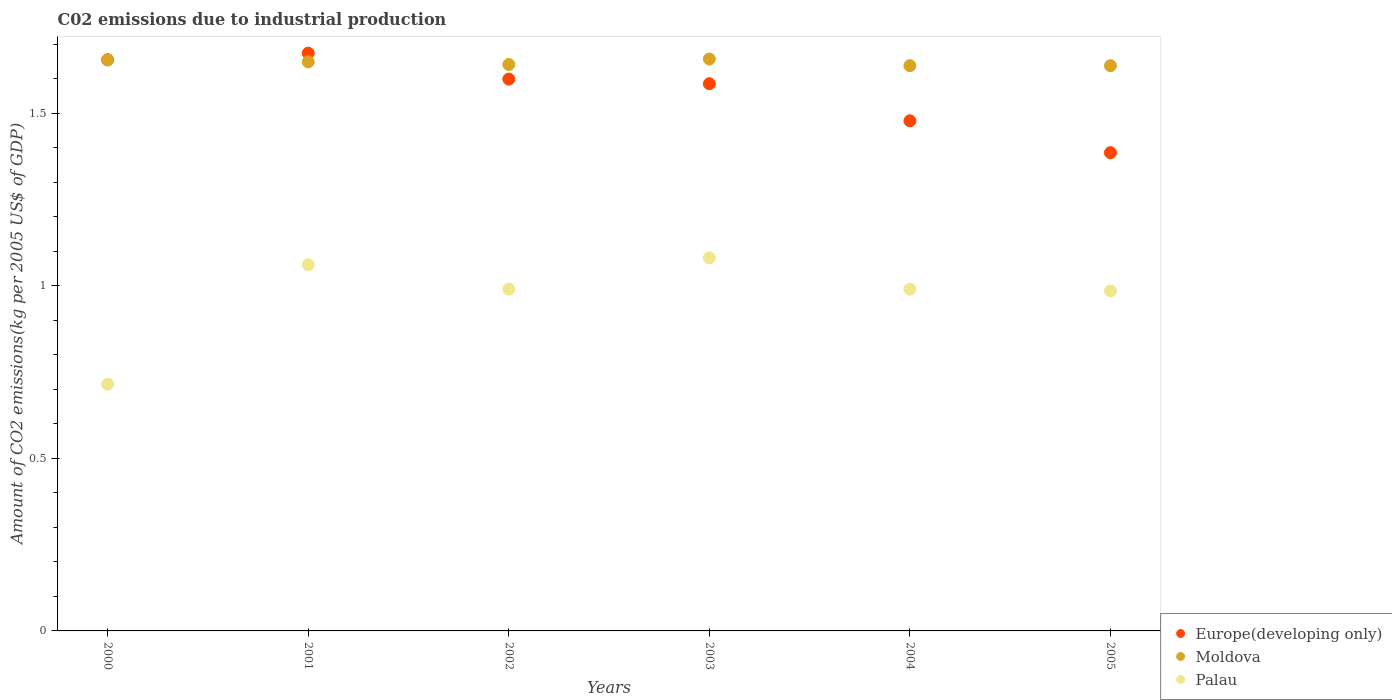What is the amount of CO2 emitted due to industrial production in Palau in 2005?
Keep it short and to the point. 0.99. Across all years, what is the maximum amount of CO2 emitted due to industrial production in Moldova?
Offer a terse response. 1.66. Across all years, what is the minimum amount of CO2 emitted due to industrial production in Europe(developing only)?
Your response must be concise. 1.39. What is the total amount of CO2 emitted due to industrial production in Palau in the graph?
Keep it short and to the point. 5.82. What is the difference between the amount of CO2 emitted due to industrial production in Moldova in 2003 and that in 2005?
Offer a terse response. 0.02. What is the difference between the amount of CO2 emitted due to industrial production in Europe(developing only) in 2002 and the amount of CO2 emitted due to industrial production in Moldova in 2003?
Offer a very short reply. -0.06. What is the average amount of CO2 emitted due to industrial production in Palau per year?
Your answer should be compact. 0.97. In the year 2002, what is the difference between the amount of CO2 emitted due to industrial production in Europe(developing only) and amount of CO2 emitted due to industrial production in Moldova?
Make the answer very short. -0.04. In how many years, is the amount of CO2 emitted due to industrial production in Europe(developing only) greater than 1.4 kg?
Provide a short and direct response. 5. What is the ratio of the amount of CO2 emitted due to industrial production in Europe(developing only) in 2003 to that in 2004?
Keep it short and to the point. 1.07. Is the difference between the amount of CO2 emitted due to industrial production in Europe(developing only) in 2001 and 2004 greater than the difference between the amount of CO2 emitted due to industrial production in Moldova in 2001 and 2004?
Your answer should be compact. Yes. What is the difference between the highest and the second highest amount of CO2 emitted due to industrial production in Moldova?
Offer a very short reply. 0. What is the difference between the highest and the lowest amount of CO2 emitted due to industrial production in Moldova?
Provide a short and direct response. 0.02. In how many years, is the amount of CO2 emitted due to industrial production in Palau greater than the average amount of CO2 emitted due to industrial production in Palau taken over all years?
Keep it short and to the point. 5. How many years are there in the graph?
Your answer should be very brief. 6. Are the values on the major ticks of Y-axis written in scientific E-notation?
Ensure brevity in your answer.  No. Where does the legend appear in the graph?
Ensure brevity in your answer.  Bottom right. What is the title of the graph?
Give a very brief answer. C02 emissions due to industrial production. What is the label or title of the X-axis?
Keep it short and to the point. Years. What is the label or title of the Y-axis?
Make the answer very short. Amount of CO2 emissions(kg per 2005 US$ of GDP). What is the Amount of CO2 emissions(kg per 2005 US$ of GDP) in Europe(developing only) in 2000?
Make the answer very short. 1.66. What is the Amount of CO2 emissions(kg per 2005 US$ of GDP) in Moldova in 2000?
Ensure brevity in your answer.  1.65. What is the Amount of CO2 emissions(kg per 2005 US$ of GDP) of Palau in 2000?
Offer a terse response. 0.71. What is the Amount of CO2 emissions(kg per 2005 US$ of GDP) in Europe(developing only) in 2001?
Give a very brief answer. 1.67. What is the Amount of CO2 emissions(kg per 2005 US$ of GDP) in Moldova in 2001?
Your answer should be very brief. 1.65. What is the Amount of CO2 emissions(kg per 2005 US$ of GDP) of Palau in 2001?
Your response must be concise. 1.06. What is the Amount of CO2 emissions(kg per 2005 US$ of GDP) in Europe(developing only) in 2002?
Make the answer very short. 1.6. What is the Amount of CO2 emissions(kg per 2005 US$ of GDP) in Moldova in 2002?
Keep it short and to the point. 1.64. What is the Amount of CO2 emissions(kg per 2005 US$ of GDP) of Palau in 2002?
Provide a short and direct response. 0.99. What is the Amount of CO2 emissions(kg per 2005 US$ of GDP) of Europe(developing only) in 2003?
Your response must be concise. 1.59. What is the Amount of CO2 emissions(kg per 2005 US$ of GDP) in Moldova in 2003?
Make the answer very short. 1.66. What is the Amount of CO2 emissions(kg per 2005 US$ of GDP) of Palau in 2003?
Offer a terse response. 1.08. What is the Amount of CO2 emissions(kg per 2005 US$ of GDP) of Europe(developing only) in 2004?
Your response must be concise. 1.48. What is the Amount of CO2 emissions(kg per 2005 US$ of GDP) of Moldova in 2004?
Offer a very short reply. 1.64. What is the Amount of CO2 emissions(kg per 2005 US$ of GDP) in Palau in 2004?
Offer a very short reply. 0.99. What is the Amount of CO2 emissions(kg per 2005 US$ of GDP) in Europe(developing only) in 2005?
Provide a succinct answer. 1.39. What is the Amount of CO2 emissions(kg per 2005 US$ of GDP) of Moldova in 2005?
Make the answer very short. 1.64. What is the Amount of CO2 emissions(kg per 2005 US$ of GDP) in Palau in 2005?
Offer a terse response. 0.99. Across all years, what is the maximum Amount of CO2 emissions(kg per 2005 US$ of GDP) in Europe(developing only)?
Keep it short and to the point. 1.67. Across all years, what is the maximum Amount of CO2 emissions(kg per 2005 US$ of GDP) in Moldova?
Ensure brevity in your answer.  1.66. Across all years, what is the maximum Amount of CO2 emissions(kg per 2005 US$ of GDP) in Palau?
Offer a very short reply. 1.08. Across all years, what is the minimum Amount of CO2 emissions(kg per 2005 US$ of GDP) in Europe(developing only)?
Your answer should be very brief. 1.39. Across all years, what is the minimum Amount of CO2 emissions(kg per 2005 US$ of GDP) of Moldova?
Your answer should be compact. 1.64. Across all years, what is the minimum Amount of CO2 emissions(kg per 2005 US$ of GDP) of Palau?
Your answer should be compact. 0.71. What is the total Amount of CO2 emissions(kg per 2005 US$ of GDP) of Europe(developing only) in the graph?
Your response must be concise. 9.38. What is the total Amount of CO2 emissions(kg per 2005 US$ of GDP) of Moldova in the graph?
Offer a terse response. 9.88. What is the total Amount of CO2 emissions(kg per 2005 US$ of GDP) in Palau in the graph?
Keep it short and to the point. 5.82. What is the difference between the Amount of CO2 emissions(kg per 2005 US$ of GDP) in Europe(developing only) in 2000 and that in 2001?
Give a very brief answer. -0.02. What is the difference between the Amount of CO2 emissions(kg per 2005 US$ of GDP) in Moldova in 2000 and that in 2001?
Ensure brevity in your answer.  0.01. What is the difference between the Amount of CO2 emissions(kg per 2005 US$ of GDP) in Palau in 2000 and that in 2001?
Make the answer very short. -0.35. What is the difference between the Amount of CO2 emissions(kg per 2005 US$ of GDP) of Europe(developing only) in 2000 and that in 2002?
Keep it short and to the point. 0.06. What is the difference between the Amount of CO2 emissions(kg per 2005 US$ of GDP) in Moldova in 2000 and that in 2002?
Ensure brevity in your answer.  0.01. What is the difference between the Amount of CO2 emissions(kg per 2005 US$ of GDP) of Palau in 2000 and that in 2002?
Your response must be concise. -0.28. What is the difference between the Amount of CO2 emissions(kg per 2005 US$ of GDP) in Europe(developing only) in 2000 and that in 2003?
Offer a terse response. 0.07. What is the difference between the Amount of CO2 emissions(kg per 2005 US$ of GDP) of Moldova in 2000 and that in 2003?
Make the answer very short. -0. What is the difference between the Amount of CO2 emissions(kg per 2005 US$ of GDP) in Palau in 2000 and that in 2003?
Keep it short and to the point. -0.37. What is the difference between the Amount of CO2 emissions(kg per 2005 US$ of GDP) in Europe(developing only) in 2000 and that in 2004?
Ensure brevity in your answer.  0.18. What is the difference between the Amount of CO2 emissions(kg per 2005 US$ of GDP) in Moldova in 2000 and that in 2004?
Offer a very short reply. 0.02. What is the difference between the Amount of CO2 emissions(kg per 2005 US$ of GDP) in Palau in 2000 and that in 2004?
Give a very brief answer. -0.28. What is the difference between the Amount of CO2 emissions(kg per 2005 US$ of GDP) of Europe(developing only) in 2000 and that in 2005?
Make the answer very short. 0.27. What is the difference between the Amount of CO2 emissions(kg per 2005 US$ of GDP) in Moldova in 2000 and that in 2005?
Give a very brief answer. 0.02. What is the difference between the Amount of CO2 emissions(kg per 2005 US$ of GDP) of Palau in 2000 and that in 2005?
Offer a very short reply. -0.27. What is the difference between the Amount of CO2 emissions(kg per 2005 US$ of GDP) of Europe(developing only) in 2001 and that in 2002?
Your answer should be very brief. 0.08. What is the difference between the Amount of CO2 emissions(kg per 2005 US$ of GDP) of Moldova in 2001 and that in 2002?
Keep it short and to the point. 0.01. What is the difference between the Amount of CO2 emissions(kg per 2005 US$ of GDP) of Palau in 2001 and that in 2002?
Your response must be concise. 0.07. What is the difference between the Amount of CO2 emissions(kg per 2005 US$ of GDP) in Europe(developing only) in 2001 and that in 2003?
Give a very brief answer. 0.09. What is the difference between the Amount of CO2 emissions(kg per 2005 US$ of GDP) in Moldova in 2001 and that in 2003?
Provide a succinct answer. -0.01. What is the difference between the Amount of CO2 emissions(kg per 2005 US$ of GDP) of Palau in 2001 and that in 2003?
Make the answer very short. -0.02. What is the difference between the Amount of CO2 emissions(kg per 2005 US$ of GDP) of Europe(developing only) in 2001 and that in 2004?
Make the answer very short. 0.2. What is the difference between the Amount of CO2 emissions(kg per 2005 US$ of GDP) in Moldova in 2001 and that in 2004?
Your response must be concise. 0.01. What is the difference between the Amount of CO2 emissions(kg per 2005 US$ of GDP) in Palau in 2001 and that in 2004?
Your response must be concise. 0.07. What is the difference between the Amount of CO2 emissions(kg per 2005 US$ of GDP) of Europe(developing only) in 2001 and that in 2005?
Provide a succinct answer. 0.29. What is the difference between the Amount of CO2 emissions(kg per 2005 US$ of GDP) of Moldova in 2001 and that in 2005?
Your response must be concise. 0.01. What is the difference between the Amount of CO2 emissions(kg per 2005 US$ of GDP) in Palau in 2001 and that in 2005?
Keep it short and to the point. 0.08. What is the difference between the Amount of CO2 emissions(kg per 2005 US$ of GDP) in Europe(developing only) in 2002 and that in 2003?
Ensure brevity in your answer.  0.01. What is the difference between the Amount of CO2 emissions(kg per 2005 US$ of GDP) in Moldova in 2002 and that in 2003?
Give a very brief answer. -0.02. What is the difference between the Amount of CO2 emissions(kg per 2005 US$ of GDP) in Palau in 2002 and that in 2003?
Ensure brevity in your answer.  -0.09. What is the difference between the Amount of CO2 emissions(kg per 2005 US$ of GDP) in Europe(developing only) in 2002 and that in 2004?
Provide a succinct answer. 0.12. What is the difference between the Amount of CO2 emissions(kg per 2005 US$ of GDP) of Moldova in 2002 and that in 2004?
Ensure brevity in your answer.  0. What is the difference between the Amount of CO2 emissions(kg per 2005 US$ of GDP) in Europe(developing only) in 2002 and that in 2005?
Offer a terse response. 0.21. What is the difference between the Amount of CO2 emissions(kg per 2005 US$ of GDP) of Moldova in 2002 and that in 2005?
Provide a succinct answer. 0. What is the difference between the Amount of CO2 emissions(kg per 2005 US$ of GDP) of Palau in 2002 and that in 2005?
Your answer should be compact. 0.01. What is the difference between the Amount of CO2 emissions(kg per 2005 US$ of GDP) in Europe(developing only) in 2003 and that in 2004?
Offer a very short reply. 0.11. What is the difference between the Amount of CO2 emissions(kg per 2005 US$ of GDP) in Moldova in 2003 and that in 2004?
Offer a very short reply. 0.02. What is the difference between the Amount of CO2 emissions(kg per 2005 US$ of GDP) in Palau in 2003 and that in 2004?
Ensure brevity in your answer.  0.09. What is the difference between the Amount of CO2 emissions(kg per 2005 US$ of GDP) in Europe(developing only) in 2003 and that in 2005?
Ensure brevity in your answer.  0.2. What is the difference between the Amount of CO2 emissions(kg per 2005 US$ of GDP) in Moldova in 2003 and that in 2005?
Your response must be concise. 0.02. What is the difference between the Amount of CO2 emissions(kg per 2005 US$ of GDP) in Palau in 2003 and that in 2005?
Provide a short and direct response. 0.1. What is the difference between the Amount of CO2 emissions(kg per 2005 US$ of GDP) of Europe(developing only) in 2004 and that in 2005?
Offer a very short reply. 0.09. What is the difference between the Amount of CO2 emissions(kg per 2005 US$ of GDP) in Moldova in 2004 and that in 2005?
Your answer should be very brief. -0. What is the difference between the Amount of CO2 emissions(kg per 2005 US$ of GDP) of Palau in 2004 and that in 2005?
Offer a very short reply. 0.01. What is the difference between the Amount of CO2 emissions(kg per 2005 US$ of GDP) of Europe(developing only) in 2000 and the Amount of CO2 emissions(kg per 2005 US$ of GDP) of Moldova in 2001?
Keep it short and to the point. 0.01. What is the difference between the Amount of CO2 emissions(kg per 2005 US$ of GDP) of Europe(developing only) in 2000 and the Amount of CO2 emissions(kg per 2005 US$ of GDP) of Palau in 2001?
Make the answer very short. 0.59. What is the difference between the Amount of CO2 emissions(kg per 2005 US$ of GDP) of Moldova in 2000 and the Amount of CO2 emissions(kg per 2005 US$ of GDP) of Palau in 2001?
Provide a succinct answer. 0.59. What is the difference between the Amount of CO2 emissions(kg per 2005 US$ of GDP) of Europe(developing only) in 2000 and the Amount of CO2 emissions(kg per 2005 US$ of GDP) of Moldova in 2002?
Make the answer very short. 0.01. What is the difference between the Amount of CO2 emissions(kg per 2005 US$ of GDP) in Europe(developing only) in 2000 and the Amount of CO2 emissions(kg per 2005 US$ of GDP) in Palau in 2002?
Give a very brief answer. 0.66. What is the difference between the Amount of CO2 emissions(kg per 2005 US$ of GDP) in Moldova in 2000 and the Amount of CO2 emissions(kg per 2005 US$ of GDP) in Palau in 2002?
Give a very brief answer. 0.66. What is the difference between the Amount of CO2 emissions(kg per 2005 US$ of GDP) in Europe(developing only) in 2000 and the Amount of CO2 emissions(kg per 2005 US$ of GDP) in Moldova in 2003?
Ensure brevity in your answer.  -0. What is the difference between the Amount of CO2 emissions(kg per 2005 US$ of GDP) in Europe(developing only) in 2000 and the Amount of CO2 emissions(kg per 2005 US$ of GDP) in Palau in 2003?
Your answer should be compact. 0.57. What is the difference between the Amount of CO2 emissions(kg per 2005 US$ of GDP) of Moldova in 2000 and the Amount of CO2 emissions(kg per 2005 US$ of GDP) of Palau in 2003?
Your answer should be compact. 0.57. What is the difference between the Amount of CO2 emissions(kg per 2005 US$ of GDP) of Europe(developing only) in 2000 and the Amount of CO2 emissions(kg per 2005 US$ of GDP) of Moldova in 2004?
Ensure brevity in your answer.  0.02. What is the difference between the Amount of CO2 emissions(kg per 2005 US$ of GDP) of Europe(developing only) in 2000 and the Amount of CO2 emissions(kg per 2005 US$ of GDP) of Palau in 2004?
Give a very brief answer. 0.67. What is the difference between the Amount of CO2 emissions(kg per 2005 US$ of GDP) of Moldova in 2000 and the Amount of CO2 emissions(kg per 2005 US$ of GDP) of Palau in 2004?
Your response must be concise. 0.66. What is the difference between the Amount of CO2 emissions(kg per 2005 US$ of GDP) in Europe(developing only) in 2000 and the Amount of CO2 emissions(kg per 2005 US$ of GDP) in Moldova in 2005?
Offer a very short reply. 0.02. What is the difference between the Amount of CO2 emissions(kg per 2005 US$ of GDP) of Europe(developing only) in 2000 and the Amount of CO2 emissions(kg per 2005 US$ of GDP) of Palau in 2005?
Offer a terse response. 0.67. What is the difference between the Amount of CO2 emissions(kg per 2005 US$ of GDP) of Moldova in 2000 and the Amount of CO2 emissions(kg per 2005 US$ of GDP) of Palau in 2005?
Ensure brevity in your answer.  0.67. What is the difference between the Amount of CO2 emissions(kg per 2005 US$ of GDP) in Europe(developing only) in 2001 and the Amount of CO2 emissions(kg per 2005 US$ of GDP) in Moldova in 2002?
Your answer should be very brief. 0.03. What is the difference between the Amount of CO2 emissions(kg per 2005 US$ of GDP) in Europe(developing only) in 2001 and the Amount of CO2 emissions(kg per 2005 US$ of GDP) in Palau in 2002?
Provide a succinct answer. 0.68. What is the difference between the Amount of CO2 emissions(kg per 2005 US$ of GDP) of Moldova in 2001 and the Amount of CO2 emissions(kg per 2005 US$ of GDP) of Palau in 2002?
Your response must be concise. 0.66. What is the difference between the Amount of CO2 emissions(kg per 2005 US$ of GDP) in Europe(developing only) in 2001 and the Amount of CO2 emissions(kg per 2005 US$ of GDP) in Moldova in 2003?
Offer a terse response. 0.02. What is the difference between the Amount of CO2 emissions(kg per 2005 US$ of GDP) in Europe(developing only) in 2001 and the Amount of CO2 emissions(kg per 2005 US$ of GDP) in Palau in 2003?
Provide a short and direct response. 0.59. What is the difference between the Amount of CO2 emissions(kg per 2005 US$ of GDP) in Moldova in 2001 and the Amount of CO2 emissions(kg per 2005 US$ of GDP) in Palau in 2003?
Keep it short and to the point. 0.57. What is the difference between the Amount of CO2 emissions(kg per 2005 US$ of GDP) of Europe(developing only) in 2001 and the Amount of CO2 emissions(kg per 2005 US$ of GDP) of Moldova in 2004?
Your response must be concise. 0.04. What is the difference between the Amount of CO2 emissions(kg per 2005 US$ of GDP) in Europe(developing only) in 2001 and the Amount of CO2 emissions(kg per 2005 US$ of GDP) in Palau in 2004?
Offer a terse response. 0.68. What is the difference between the Amount of CO2 emissions(kg per 2005 US$ of GDP) of Moldova in 2001 and the Amount of CO2 emissions(kg per 2005 US$ of GDP) of Palau in 2004?
Offer a terse response. 0.66. What is the difference between the Amount of CO2 emissions(kg per 2005 US$ of GDP) in Europe(developing only) in 2001 and the Amount of CO2 emissions(kg per 2005 US$ of GDP) in Moldova in 2005?
Offer a terse response. 0.04. What is the difference between the Amount of CO2 emissions(kg per 2005 US$ of GDP) in Europe(developing only) in 2001 and the Amount of CO2 emissions(kg per 2005 US$ of GDP) in Palau in 2005?
Your response must be concise. 0.69. What is the difference between the Amount of CO2 emissions(kg per 2005 US$ of GDP) in Moldova in 2001 and the Amount of CO2 emissions(kg per 2005 US$ of GDP) in Palau in 2005?
Your answer should be very brief. 0.66. What is the difference between the Amount of CO2 emissions(kg per 2005 US$ of GDP) in Europe(developing only) in 2002 and the Amount of CO2 emissions(kg per 2005 US$ of GDP) in Moldova in 2003?
Keep it short and to the point. -0.06. What is the difference between the Amount of CO2 emissions(kg per 2005 US$ of GDP) in Europe(developing only) in 2002 and the Amount of CO2 emissions(kg per 2005 US$ of GDP) in Palau in 2003?
Your response must be concise. 0.52. What is the difference between the Amount of CO2 emissions(kg per 2005 US$ of GDP) in Moldova in 2002 and the Amount of CO2 emissions(kg per 2005 US$ of GDP) in Palau in 2003?
Make the answer very short. 0.56. What is the difference between the Amount of CO2 emissions(kg per 2005 US$ of GDP) in Europe(developing only) in 2002 and the Amount of CO2 emissions(kg per 2005 US$ of GDP) in Moldova in 2004?
Your response must be concise. -0.04. What is the difference between the Amount of CO2 emissions(kg per 2005 US$ of GDP) of Europe(developing only) in 2002 and the Amount of CO2 emissions(kg per 2005 US$ of GDP) of Palau in 2004?
Your response must be concise. 0.61. What is the difference between the Amount of CO2 emissions(kg per 2005 US$ of GDP) of Moldova in 2002 and the Amount of CO2 emissions(kg per 2005 US$ of GDP) of Palau in 2004?
Your answer should be very brief. 0.65. What is the difference between the Amount of CO2 emissions(kg per 2005 US$ of GDP) in Europe(developing only) in 2002 and the Amount of CO2 emissions(kg per 2005 US$ of GDP) in Moldova in 2005?
Make the answer very short. -0.04. What is the difference between the Amount of CO2 emissions(kg per 2005 US$ of GDP) in Europe(developing only) in 2002 and the Amount of CO2 emissions(kg per 2005 US$ of GDP) in Palau in 2005?
Keep it short and to the point. 0.61. What is the difference between the Amount of CO2 emissions(kg per 2005 US$ of GDP) of Moldova in 2002 and the Amount of CO2 emissions(kg per 2005 US$ of GDP) of Palau in 2005?
Offer a very short reply. 0.66. What is the difference between the Amount of CO2 emissions(kg per 2005 US$ of GDP) of Europe(developing only) in 2003 and the Amount of CO2 emissions(kg per 2005 US$ of GDP) of Moldova in 2004?
Ensure brevity in your answer.  -0.05. What is the difference between the Amount of CO2 emissions(kg per 2005 US$ of GDP) in Europe(developing only) in 2003 and the Amount of CO2 emissions(kg per 2005 US$ of GDP) in Palau in 2004?
Your answer should be very brief. 0.6. What is the difference between the Amount of CO2 emissions(kg per 2005 US$ of GDP) in Moldova in 2003 and the Amount of CO2 emissions(kg per 2005 US$ of GDP) in Palau in 2004?
Offer a terse response. 0.67. What is the difference between the Amount of CO2 emissions(kg per 2005 US$ of GDP) of Europe(developing only) in 2003 and the Amount of CO2 emissions(kg per 2005 US$ of GDP) of Moldova in 2005?
Make the answer very short. -0.05. What is the difference between the Amount of CO2 emissions(kg per 2005 US$ of GDP) of Europe(developing only) in 2003 and the Amount of CO2 emissions(kg per 2005 US$ of GDP) of Palau in 2005?
Provide a short and direct response. 0.6. What is the difference between the Amount of CO2 emissions(kg per 2005 US$ of GDP) of Moldova in 2003 and the Amount of CO2 emissions(kg per 2005 US$ of GDP) of Palau in 2005?
Provide a succinct answer. 0.67. What is the difference between the Amount of CO2 emissions(kg per 2005 US$ of GDP) of Europe(developing only) in 2004 and the Amount of CO2 emissions(kg per 2005 US$ of GDP) of Moldova in 2005?
Your response must be concise. -0.16. What is the difference between the Amount of CO2 emissions(kg per 2005 US$ of GDP) in Europe(developing only) in 2004 and the Amount of CO2 emissions(kg per 2005 US$ of GDP) in Palau in 2005?
Give a very brief answer. 0.49. What is the difference between the Amount of CO2 emissions(kg per 2005 US$ of GDP) of Moldova in 2004 and the Amount of CO2 emissions(kg per 2005 US$ of GDP) of Palau in 2005?
Offer a terse response. 0.65. What is the average Amount of CO2 emissions(kg per 2005 US$ of GDP) in Europe(developing only) per year?
Your answer should be very brief. 1.56. What is the average Amount of CO2 emissions(kg per 2005 US$ of GDP) of Moldova per year?
Offer a terse response. 1.65. What is the average Amount of CO2 emissions(kg per 2005 US$ of GDP) of Palau per year?
Offer a very short reply. 0.97. In the year 2000, what is the difference between the Amount of CO2 emissions(kg per 2005 US$ of GDP) in Europe(developing only) and Amount of CO2 emissions(kg per 2005 US$ of GDP) in Moldova?
Provide a short and direct response. 0. In the year 2000, what is the difference between the Amount of CO2 emissions(kg per 2005 US$ of GDP) of Europe(developing only) and Amount of CO2 emissions(kg per 2005 US$ of GDP) of Palau?
Make the answer very short. 0.94. In the year 2000, what is the difference between the Amount of CO2 emissions(kg per 2005 US$ of GDP) in Moldova and Amount of CO2 emissions(kg per 2005 US$ of GDP) in Palau?
Offer a terse response. 0.94. In the year 2001, what is the difference between the Amount of CO2 emissions(kg per 2005 US$ of GDP) of Europe(developing only) and Amount of CO2 emissions(kg per 2005 US$ of GDP) of Moldova?
Your response must be concise. 0.03. In the year 2001, what is the difference between the Amount of CO2 emissions(kg per 2005 US$ of GDP) of Europe(developing only) and Amount of CO2 emissions(kg per 2005 US$ of GDP) of Palau?
Offer a terse response. 0.61. In the year 2001, what is the difference between the Amount of CO2 emissions(kg per 2005 US$ of GDP) of Moldova and Amount of CO2 emissions(kg per 2005 US$ of GDP) of Palau?
Provide a succinct answer. 0.59. In the year 2002, what is the difference between the Amount of CO2 emissions(kg per 2005 US$ of GDP) of Europe(developing only) and Amount of CO2 emissions(kg per 2005 US$ of GDP) of Moldova?
Provide a succinct answer. -0.04. In the year 2002, what is the difference between the Amount of CO2 emissions(kg per 2005 US$ of GDP) in Europe(developing only) and Amount of CO2 emissions(kg per 2005 US$ of GDP) in Palau?
Your answer should be compact. 0.61. In the year 2002, what is the difference between the Amount of CO2 emissions(kg per 2005 US$ of GDP) in Moldova and Amount of CO2 emissions(kg per 2005 US$ of GDP) in Palau?
Provide a succinct answer. 0.65. In the year 2003, what is the difference between the Amount of CO2 emissions(kg per 2005 US$ of GDP) in Europe(developing only) and Amount of CO2 emissions(kg per 2005 US$ of GDP) in Moldova?
Provide a succinct answer. -0.07. In the year 2003, what is the difference between the Amount of CO2 emissions(kg per 2005 US$ of GDP) of Europe(developing only) and Amount of CO2 emissions(kg per 2005 US$ of GDP) of Palau?
Your response must be concise. 0.51. In the year 2003, what is the difference between the Amount of CO2 emissions(kg per 2005 US$ of GDP) in Moldova and Amount of CO2 emissions(kg per 2005 US$ of GDP) in Palau?
Provide a succinct answer. 0.58. In the year 2004, what is the difference between the Amount of CO2 emissions(kg per 2005 US$ of GDP) in Europe(developing only) and Amount of CO2 emissions(kg per 2005 US$ of GDP) in Moldova?
Your answer should be compact. -0.16. In the year 2004, what is the difference between the Amount of CO2 emissions(kg per 2005 US$ of GDP) of Europe(developing only) and Amount of CO2 emissions(kg per 2005 US$ of GDP) of Palau?
Make the answer very short. 0.49. In the year 2004, what is the difference between the Amount of CO2 emissions(kg per 2005 US$ of GDP) of Moldova and Amount of CO2 emissions(kg per 2005 US$ of GDP) of Palau?
Give a very brief answer. 0.65. In the year 2005, what is the difference between the Amount of CO2 emissions(kg per 2005 US$ of GDP) of Europe(developing only) and Amount of CO2 emissions(kg per 2005 US$ of GDP) of Moldova?
Give a very brief answer. -0.25. In the year 2005, what is the difference between the Amount of CO2 emissions(kg per 2005 US$ of GDP) in Europe(developing only) and Amount of CO2 emissions(kg per 2005 US$ of GDP) in Palau?
Provide a short and direct response. 0.4. In the year 2005, what is the difference between the Amount of CO2 emissions(kg per 2005 US$ of GDP) in Moldova and Amount of CO2 emissions(kg per 2005 US$ of GDP) in Palau?
Your response must be concise. 0.65. What is the ratio of the Amount of CO2 emissions(kg per 2005 US$ of GDP) in Moldova in 2000 to that in 2001?
Your answer should be compact. 1. What is the ratio of the Amount of CO2 emissions(kg per 2005 US$ of GDP) in Palau in 2000 to that in 2001?
Your response must be concise. 0.67. What is the ratio of the Amount of CO2 emissions(kg per 2005 US$ of GDP) of Europe(developing only) in 2000 to that in 2002?
Provide a succinct answer. 1.04. What is the ratio of the Amount of CO2 emissions(kg per 2005 US$ of GDP) in Palau in 2000 to that in 2002?
Ensure brevity in your answer.  0.72. What is the ratio of the Amount of CO2 emissions(kg per 2005 US$ of GDP) of Europe(developing only) in 2000 to that in 2003?
Provide a succinct answer. 1.04. What is the ratio of the Amount of CO2 emissions(kg per 2005 US$ of GDP) in Palau in 2000 to that in 2003?
Ensure brevity in your answer.  0.66. What is the ratio of the Amount of CO2 emissions(kg per 2005 US$ of GDP) of Europe(developing only) in 2000 to that in 2004?
Offer a terse response. 1.12. What is the ratio of the Amount of CO2 emissions(kg per 2005 US$ of GDP) in Palau in 2000 to that in 2004?
Your answer should be compact. 0.72. What is the ratio of the Amount of CO2 emissions(kg per 2005 US$ of GDP) of Europe(developing only) in 2000 to that in 2005?
Keep it short and to the point. 1.19. What is the ratio of the Amount of CO2 emissions(kg per 2005 US$ of GDP) of Palau in 2000 to that in 2005?
Make the answer very short. 0.73. What is the ratio of the Amount of CO2 emissions(kg per 2005 US$ of GDP) in Europe(developing only) in 2001 to that in 2002?
Your answer should be very brief. 1.05. What is the ratio of the Amount of CO2 emissions(kg per 2005 US$ of GDP) in Palau in 2001 to that in 2002?
Your answer should be compact. 1.07. What is the ratio of the Amount of CO2 emissions(kg per 2005 US$ of GDP) in Europe(developing only) in 2001 to that in 2003?
Provide a succinct answer. 1.06. What is the ratio of the Amount of CO2 emissions(kg per 2005 US$ of GDP) in Moldova in 2001 to that in 2003?
Your answer should be compact. 0.99. What is the ratio of the Amount of CO2 emissions(kg per 2005 US$ of GDP) of Palau in 2001 to that in 2003?
Keep it short and to the point. 0.98. What is the ratio of the Amount of CO2 emissions(kg per 2005 US$ of GDP) in Europe(developing only) in 2001 to that in 2004?
Provide a succinct answer. 1.13. What is the ratio of the Amount of CO2 emissions(kg per 2005 US$ of GDP) of Palau in 2001 to that in 2004?
Your response must be concise. 1.07. What is the ratio of the Amount of CO2 emissions(kg per 2005 US$ of GDP) in Europe(developing only) in 2001 to that in 2005?
Your answer should be compact. 1.21. What is the ratio of the Amount of CO2 emissions(kg per 2005 US$ of GDP) in Palau in 2001 to that in 2005?
Give a very brief answer. 1.08. What is the ratio of the Amount of CO2 emissions(kg per 2005 US$ of GDP) in Europe(developing only) in 2002 to that in 2003?
Ensure brevity in your answer.  1.01. What is the ratio of the Amount of CO2 emissions(kg per 2005 US$ of GDP) of Palau in 2002 to that in 2003?
Keep it short and to the point. 0.92. What is the ratio of the Amount of CO2 emissions(kg per 2005 US$ of GDP) in Europe(developing only) in 2002 to that in 2004?
Give a very brief answer. 1.08. What is the ratio of the Amount of CO2 emissions(kg per 2005 US$ of GDP) in Palau in 2002 to that in 2004?
Ensure brevity in your answer.  1. What is the ratio of the Amount of CO2 emissions(kg per 2005 US$ of GDP) of Europe(developing only) in 2002 to that in 2005?
Your answer should be very brief. 1.15. What is the ratio of the Amount of CO2 emissions(kg per 2005 US$ of GDP) in Moldova in 2002 to that in 2005?
Provide a short and direct response. 1. What is the ratio of the Amount of CO2 emissions(kg per 2005 US$ of GDP) of Palau in 2002 to that in 2005?
Provide a short and direct response. 1.01. What is the ratio of the Amount of CO2 emissions(kg per 2005 US$ of GDP) of Europe(developing only) in 2003 to that in 2004?
Give a very brief answer. 1.07. What is the ratio of the Amount of CO2 emissions(kg per 2005 US$ of GDP) of Moldova in 2003 to that in 2004?
Provide a short and direct response. 1.01. What is the ratio of the Amount of CO2 emissions(kg per 2005 US$ of GDP) of Palau in 2003 to that in 2004?
Ensure brevity in your answer.  1.09. What is the ratio of the Amount of CO2 emissions(kg per 2005 US$ of GDP) of Europe(developing only) in 2003 to that in 2005?
Provide a succinct answer. 1.14. What is the ratio of the Amount of CO2 emissions(kg per 2005 US$ of GDP) in Moldova in 2003 to that in 2005?
Make the answer very short. 1.01. What is the ratio of the Amount of CO2 emissions(kg per 2005 US$ of GDP) in Palau in 2003 to that in 2005?
Make the answer very short. 1.1. What is the ratio of the Amount of CO2 emissions(kg per 2005 US$ of GDP) in Europe(developing only) in 2004 to that in 2005?
Keep it short and to the point. 1.07. What is the difference between the highest and the second highest Amount of CO2 emissions(kg per 2005 US$ of GDP) in Europe(developing only)?
Ensure brevity in your answer.  0.02. What is the difference between the highest and the second highest Amount of CO2 emissions(kg per 2005 US$ of GDP) in Moldova?
Give a very brief answer. 0. What is the difference between the highest and the second highest Amount of CO2 emissions(kg per 2005 US$ of GDP) in Palau?
Keep it short and to the point. 0.02. What is the difference between the highest and the lowest Amount of CO2 emissions(kg per 2005 US$ of GDP) of Europe(developing only)?
Make the answer very short. 0.29. What is the difference between the highest and the lowest Amount of CO2 emissions(kg per 2005 US$ of GDP) of Moldova?
Keep it short and to the point. 0.02. What is the difference between the highest and the lowest Amount of CO2 emissions(kg per 2005 US$ of GDP) of Palau?
Ensure brevity in your answer.  0.37. 